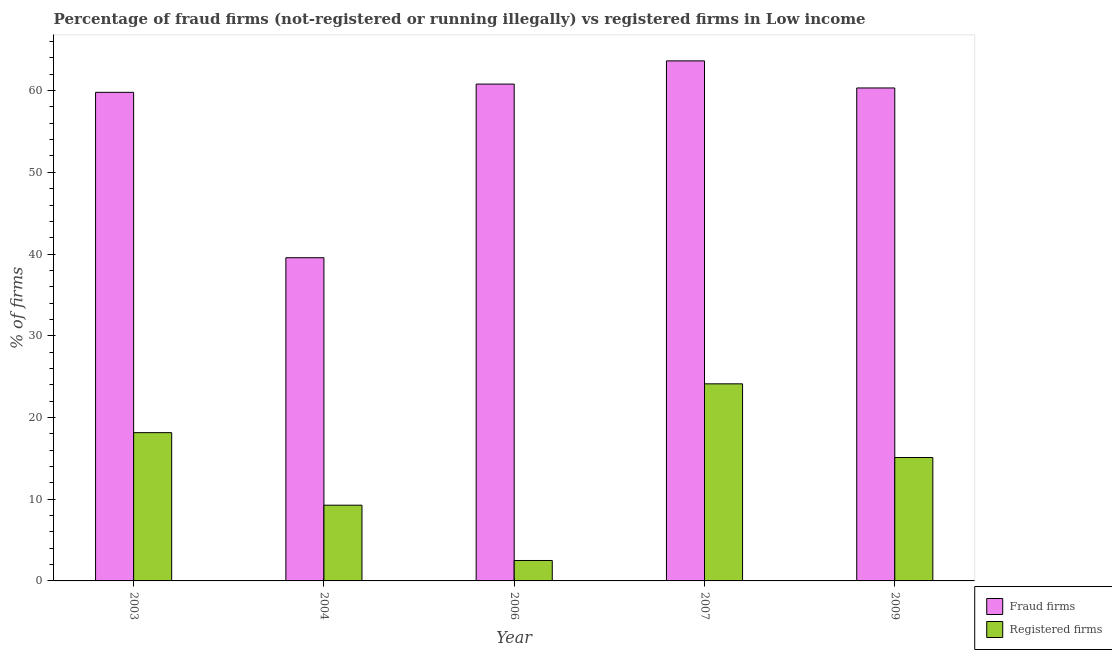How many groups of bars are there?
Keep it short and to the point. 5. Are the number of bars on each tick of the X-axis equal?
Ensure brevity in your answer.  Yes. How many bars are there on the 1st tick from the right?
Make the answer very short. 2. In how many cases, is the number of bars for a given year not equal to the number of legend labels?
Provide a succinct answer. 0. What is the percentage of fraud firms in 2003?
Your answer should be very brief. 59.79. Across all years, what is the maximum percentage of fraud firms?
Provide a succinct answer. 63.64. Across all years, what is the minimum percentage of fraud firms?
Your answer should be very brief. 39.55. What is the total percentage of registered firms in the graph?
Make the answer very short. 69.13. What is the difference between the percentage of registered firms in 2007 and that in 2009?
Provide a short and direct response. 9.02. What is the difference between the percentage of fraud firms in 2009 and the percentage of registered firms in 2003?
Your answer should be very brief. 0.54. What is the average percentage of fraud firms per year?
Provide a succinct answer. 56.82. In the year 2007, what is the difference between the percentage of fraud firms and percentage of registered firms?
Provide a succinct answer. 0. What is the ratio of the percentage of fraud firms in 2007 to that in 2009?
Offer a terse response. 1.05. Is the percentage of fraud firms in 2006 less than that in 2009?
Your answer should be very brief. No. What is the difference between the highest and the second highest percentage of fraud firms?
Ensure brevity in your answer.  2.84. What is the difference between the highest and the lowest percentage of fraud firms?
Give a very brief answer. 24.09. In how many years, is the percentage of registered firms greater than the average percentage of registered firms taken over all years?
Offer a terse response. 3. What does the 2nd bar from the left in 2003 represents?
Make the answer very short. Registered firms. What does the 2nd bar from the right in 2007 represents?
Your answer should be compact. Fraud firms. How many bars are there?
Your answer should be compact. 10. How many years are there in the graph?
Provide a short and direct response. 5. What is the difference between two consecutive major ticks on the Y-axis?
Give a very brief answer. 10. Are the values on the major ticks of Y-axis written in scientific E-notation?
Keep it short and to the point. No. Does the graph contain any zero values?
Provide a short and direct response. No. Does the graph contain grids?
Ensure brevity in your answer.  No. How many legend labels are there?
Your answer should be compact. 2. How are the legend labels stacked?
Your response must be concise. Vertical. What is the title of the graph?
Give a very brief answer. Percentage of fraud firms (not-registered or running illegally) vs registered firms in Low income. Does "Investment in Transport" appear as one of the legend labels in the graph?
Provide a succinct answer. No. What is the label or title of the X-axis?
Your response must be concise. Year. What is the label or title of the Y-axis?
Keep it short and to the point. % of firms. What is the % of firms of Fraud firms in 2003?
Provide a short and direct response. 59.79. What is the % of firms in Registered firms in 2003?
Offer a very short reply. 18.15. What is the % of firms of Fraud firms in 2004?
Offer a terse response. 39.55. What is the % of firms of Registered firms in 2004?
Ensure brevity in your answer.  9.27. What is the % of firms in Fraud firms in 2006?
Provide a short and direct response. 60.8. What is the % of firms in Fraud firms in 2007?
Ensure brevity in your answer.  63.64. What is the % of firms of Registered firms in 2007?
Make the answer very short. 24.12. What is the % of firms in Fraud firms in 2009?
Give a very brief answer. 60.33. Across all years, what is the maximum % of firms in Fraud firms?
Your response must be concise. 63.64. Across all years, what is the maximum % of firms in Registered firms?
Ensure brevity in your answer.  24.12. Across all years, what is the minimum % of firms of Fraud firms?
Provide a short and direct response. 39.55. What is the total % of firms in Fraud firms in the graph?
Offer a terse response. 284.1. What is the total % of firms in Registered firms in the graph?
Offer a very short reply. 69.13. What is the difference between the % of firms in Fraud firms in 2003 and that in 2004?
Your answer should be compact. 20.24. What is the difference between the % of firms in Registered firms in 2003 and that in 2004?
Give a very brief answer. 8.88. What is the difference between the % of firms of Fraud firms in 2003 and that in 2006?
Your response must be concise. -1.01. What is the difference between the % of firms in Registered firms in 2003 and that in 2006?
Your answer should be very brief. 15.65. What is the difference between the % of firms of Fraud firms in 2003 and that in 2007?
Offer a terse response. -3.85. What is the difference between the % of firms in Registered firms in 2003 and that in 2007?
Make the answer very short. -5.97. What is the difference between the % of firms in Fraud firms in 2003 and that in 2009?
Give a very brief answer. -0.54. What is the difference between the % of firms of Registered firms in 2003 and that in 2009?
Provide a succinct answer. 3.05. What is the difference between the % of firms in Fraud firms in 2004 and that in 2006?
Your answer should be very brief. -21.25. What is the difference between the % of firms in Registered firms in 2004 and that in 2006?
Ensure brevity in your answer.  6.77. What is the difference between the % of firms of Fraud firms in 2004 and that in 2007?
Ensure brevity in your answer.  -24.09. What is the difference between the % of firms in Registered firms in 2004 and that in 2007?
Your answer should be very brief. -14.85. What is the difference between the % of firms of Fraud firms in 2004 and that in 2009?
Make the answer very short. -20.77. What is the difference between the % of firms in Registered firms in 2004 and that in 2009?
Make the answer very short. -5.83. What is the difference between the % of firms of Fraud firms in 2006 and that in 2007?
Offer a terse response. -2.84. What is the difference between the % of firms of Registered firms in 2006 and that in 2007?
Keep it short and to the point. -21.62. What is the difference between the % of firms of Fraud firms in 2006 and that in 2009?
Ensure brevity in your answer.  0.47. What is the difference between the % of firms of Registered firms in 2006 and that in 2009?
Provide a succinct answer. -12.6. What is the difference between the % of firms in Fraud firms in 2007 and that in 2009?
Keep it short and to the point. 3.31. What is the difference between the % of firms of Registered firms in 2007 and that in 2009?
Keep it short and to the point. 9.02. What is the difference between the % of firms of Fraud firms in 2003 and the % of firms of Registered firms in 2004?
Make the answer very short. 50.52. What is the difference between the % of firms of Fraud firms in 2003 and the % of firms of Registered firms in 2006?
Your answer should be very brief. 57.29. What is the difference between the % of firms in Fraud firms in 2003 and the % of firms in Registered firms in 2007?
Your answer should be compact. 35.67. What is the difference between the % of firms of Fraud firms in 2003 and the % of firms of Registered firms in 2009?
Make the answer very short. 44.69. What is the difference between the % of firms of Fraud firms in 2004 and the % of firms of Registered firms in 2006?
Your response must be concise. 37.05. What is the difference between the % of firms in Fraud firms in 2004 and the % of firms in Registered firms in 2007?
Offer a terse response. 15.43. What is the difference between the % of firms of Fraud firms in 2004 and the % of firms of Registered firms in 2009?
Your answer should be very brief. 24.45. What is the difference between the % of firms of Fraud firms in 2006 and the % of firms of Registered firms in 2007?
Make the answer very short. 36.68. What is the difference between the % of firms of Fraud firms in 2006 and the % of firms of Registered firms in 2009?
Keep it short and to the point. 45.7. What is the difference between the % of firms in Fraud firms in 2007 and the % of firms in Registered firms in 2009?
Make the answer very short. 48.54. What is the average % of firms of Fraud firms per year?
Give a very brief answer. 56.82. What is the average % of firms in Registered firms per year?
Ensure brevity in your answer.  13.83. In the year 2003, what is the difference between the % of firms of Fraud firms and % of firms of Registered firms?
Ensure brevity in your answer.  41.64. In the year 2004, what is the difference between the % of firms in Fraud firms and % of firms in Registered firms?
Offer a terse response. 30.28. In the year 2006, what is the difference between the % of firms in Fraud firms and % of firms in Registered firms?
Make the answer very short. 58.3. In the year 2007, what is the difference between the % of firms of Fraud firms and % of firms of Registered firms?
Make the answer very short. 39.52. In the year 2009, what is the difference between the % of firms of Fraud firms and % of firms of Registered firms?
Your response must be concise. 45.23. What is the ratio of the % of firms in Fraud firms in 2003 to that in 2004?
Keep it short and to the point. 1.51. What is the ratio of the % of firms of Registered firms in 2003 to that in 2004?
Give a very brief answer. 1.96. What is the ratio of the % of firms of Fraud firms in 2003 to that in 2006?
Make the answer very short. 0.98. What is the ratio of the % of firms in Registered firms in 2003 to that in 2006?
Keep it short and to the point. 7.26. What is the ratio of the % of firms in Fraud firms in 2003 to that in 2007?
Your answer should be very brief. 0.94. What is the ratio of the % of firms in Registered firms in 2003 to that in 2007?
Provide a succinct answer. 0.75. What is the ratio of the % of firms of Fraud firms in 2003 to that in 2009?
Keep it short and to the point. 0.99. What is the ratio of the % of firms in Registered firms in 2003 to that in 2009?
Ensure brevity in your answer.  1.2. What is the ratio of the % of firms of Fraud firms in 2004 to that in 2006?
Offer a terse response. 0.65. What is the ratio of the % of firms of Registered firms in 2004 to that in 2006?
Provide a short and direct response. 3.71. What is the ratio of the % of firms of Fraud firms in 2004 to that in 2007?
Provide a succinct answer. 0.62. What is the ratio of the % of firms of Registered firms in 2004 to that in 2007?
Give a very brief answer. 0.38. What is the ratio of the % of firms of Fraud firms in 2004 to that in 2009?
Your response must be concise. 0.66. What is the ratio of the % of firms of Registered firms in 2004 to that in 2009?
Offer a very short reply. 0.61. What is the ratio of the % of firms in Fraud firms in 2006 to that in 2007?
Your answer should be very brief. 0.96. What is the ratio of the % of firms of Registered firms in 2006 to that in 2007?
Your response must be concise. 0.1. What is the ratio of the % of firms of Fraud firms in 2006 to that in 2009?
Your answer should be very brief. 1.01. What is the ratio of the % of firms in Registered firms in 2006 to that in 2009?
Your response must be concise. 0.17. What is the ratio of the % of firms in Fraud firms in 2007 to that in 2009?
Give a very brief answer. 1.05. What is the ratio of the % of firms in Registered firms in 2007 to that in 2009?
Ensure brevity in your answer.  1.6. What is the difference between the highest and the second highest % of firms of Fraud firms?
Give a very brief answer. 2.84. What is the difference between the highest and the second highest % of firms in Registered firms?
Give a very brief answer. 5.97. What is the difference between the highest and the lowest % of firms in Fraud firms?
Keep it short and to the point. 24.09. What is the difference between the highest and the lowest % of firms of Registered firms?
Offer a terse response. 21.62. 